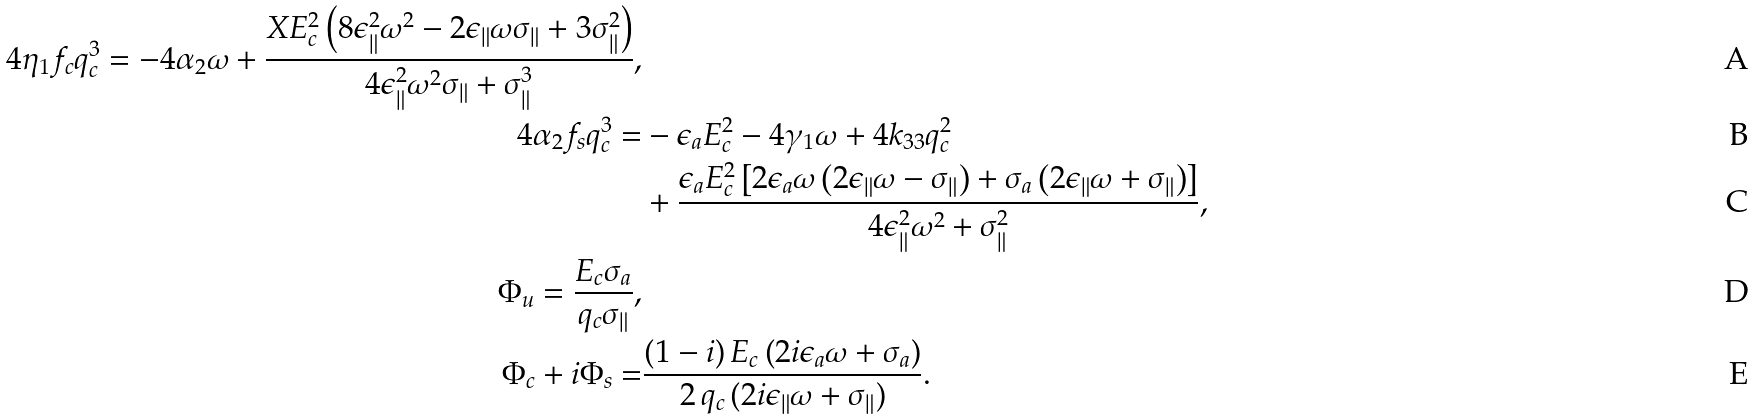<formula> <loc_0><loc_0><loc_500><loc_500>4 { { \eta } _ { 1 } } { f _ { c } } { q _ { c } ^ { 3 } } = - 4 { { \alpha } _ { 2 } } \omega + { \frac { { X } { E _ { c } ^ { 2 } } \left ( 8 { { \epsilon } _ { \| } ^ { 2 } } { \omega ^ { 2 } } - 2 { { \epsilon } _ { \| } } \omega { { \sigma } _ { \| } } + 3 { { \sigma } _ { \| } ^ { 2 } } \right ) } { 4 { { \epsilon } _ { \| } ^ { 2 } } { \omega ^ { 2 } } { { \sigma } _ { \| } } + { { \sigma } _ { \| } ^ { 3 } } } } , \\ 4 { { \alpha } _ { 2 } } { f _ { s } } { q _ { c } ^ { 3 } } = & - { { \epsilon } _ { a } } { E _ { c } ^ { 2 } } - 4 { { \gamma } _ { 1 } } \omega + 4 { k _ { 3 3 } } { q _ { c } ^ { 2 } } \\ & + { \frac { { { \epsilon } _ { a } } { E _ { c } ^ { 2 } } \left [ 2 { { \epsilon } _ { a } } \omega \left ( 2 { { \epsilon } _ { \| } } \omega - { { \sigma } _ { \| } } \right ) + { { \sigma } _ { a } } \left ( 2 { { \epsilon } _ { \| } } \omega + { { \sigma } _ { \| } } \right ) \right ] } { 4 { { \epsilon } _ { \| } ^ { 2 } } { \omega ^ { 2 } } + { { \sigma } _ { \| } ^ { 2 } } } } , \\ { { { { \Phi } _ { u } } } = { { \frac { { E _ { c } } { { \sigma } _ { a } } } { { q _ { c } } { { \sigma } _ { \| } } } } } } , \\ { { \Phi } _ { c } } + i { { \Phi } _ { s } } = & { \frac { \left ( 1 - i \right ) { E _ { c } } \left ( 2 i { { \epsilon } _ { a } } \omega + { { \sigma } _ { a } } \right ) } { 2 \, q _ { c } \, ( 2 i { { \epsilon } _ { \| } } \omega + { { \sigma } _ { \| } } ) } } .</formula> 